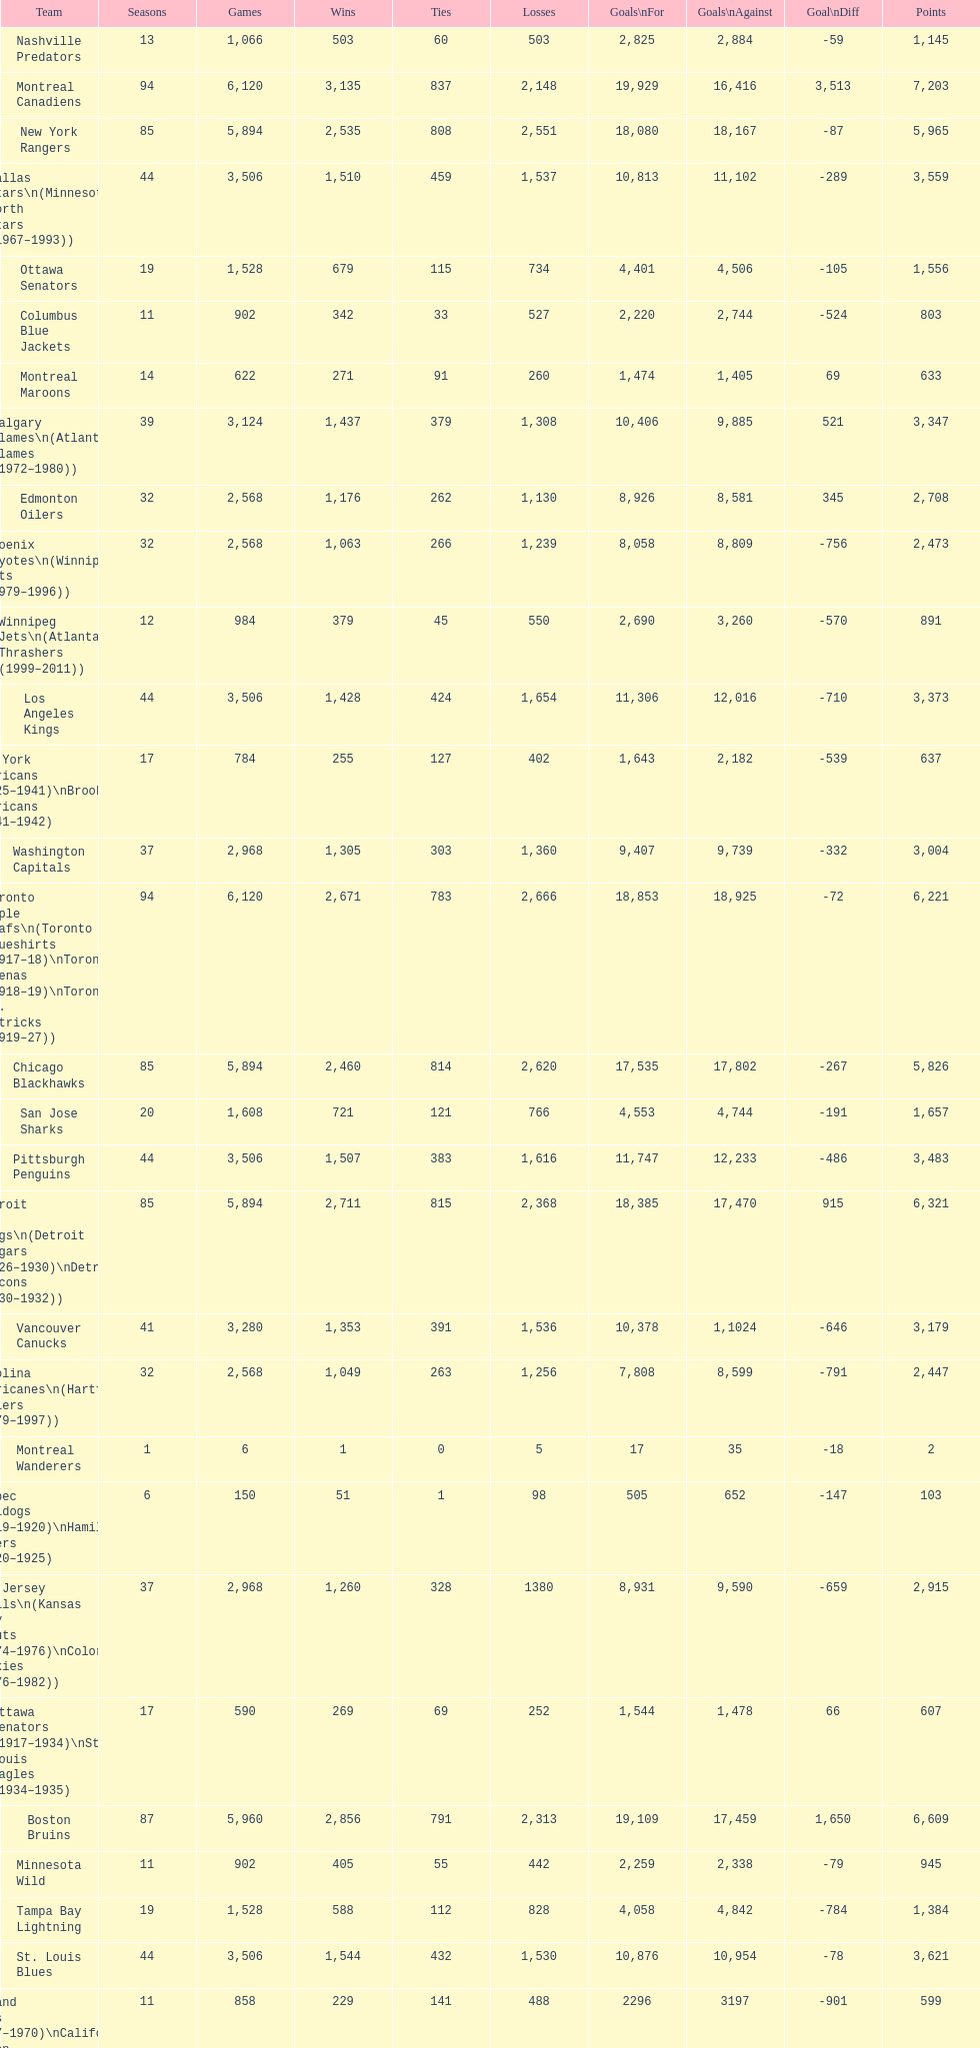Which team was last in terms of points up until this point? Montreal Wanderers. 